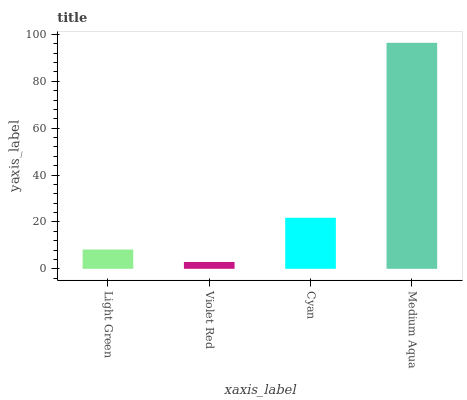Is Violet Red the minimum?
Answer yes or no. Yes. Is Medium Aqua the maximum?
Answer yes or no. Yes. Is Cyan the minimum?
Answer yes or no. No. Is Cyan the maximum?
Answer yes or no. No. Is Cyan greater than Violet Red?
Answer yes or no. Yes. Is Violet Red less than Cyan?
Answer yes or no. Yes. Is Violet Red greater than Cyan?
Answer yes or no. No. Is Cyan less than Violet Red?
Answer yes or no. No. Is Cyan the high median?
Answer yes or no. Yes. Is Light Green the low median?
Answer yes or no. Yes. Is Medium Aqua the high median?
Answer yes or no. No. Is Cyan the low median?
Answer yes or no. No. 